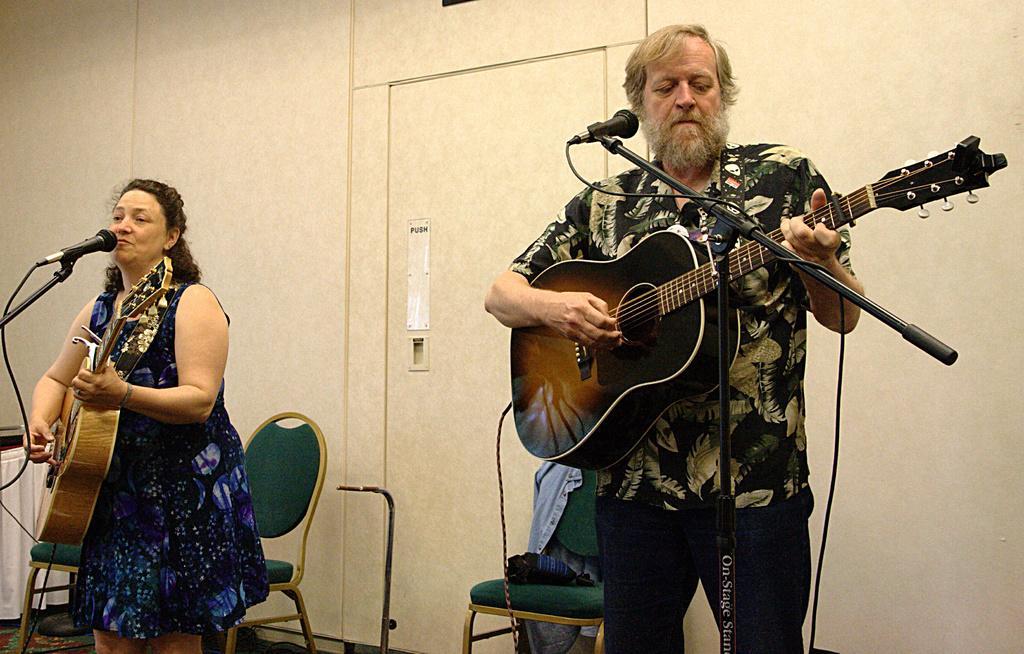Can you describe this image briefly? The two persons are standing. They are playing a guitar. On the left side person is singing a song. We can see in background white color wall. 